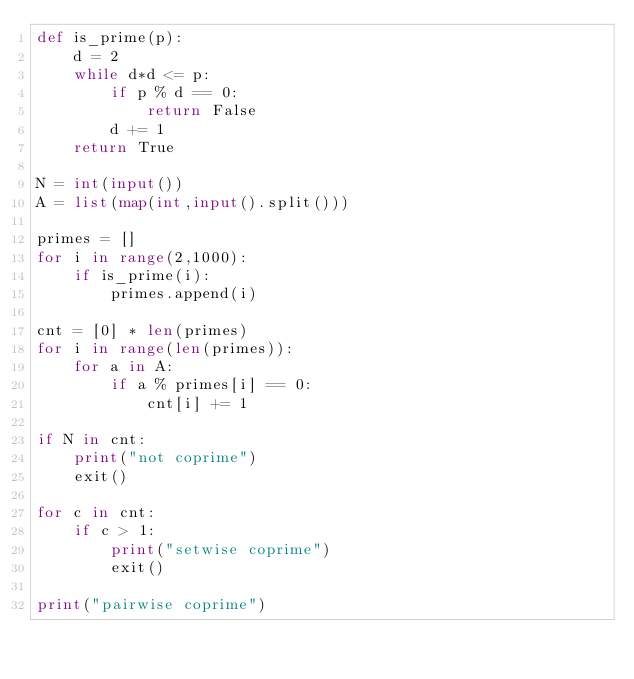<code> <loc_0><loc_0><loc_500><loc_500><_Python_>def is_prime(p):
    d = 2
    while d*d <= p:
        if p % d == 0:
            return False
        d += 1
    return True

N = int(input())
A = list(map(int,input().split()))

primes = []
for i in range(2,1000):
    if is_prime(i):
        primes.append(i)

cnt = [0] * len(primes)
for i in range(len(primes)):
    for a in A:
        if a % primes[i] == 0:
            cnt[i] += 1
    
if N in cnt:
    print("not coprime")
    exit()

for c in cnt:
    if c > 1:
        print("setwise coprime")
        exit()

print("pairwise coprime")
</code> 